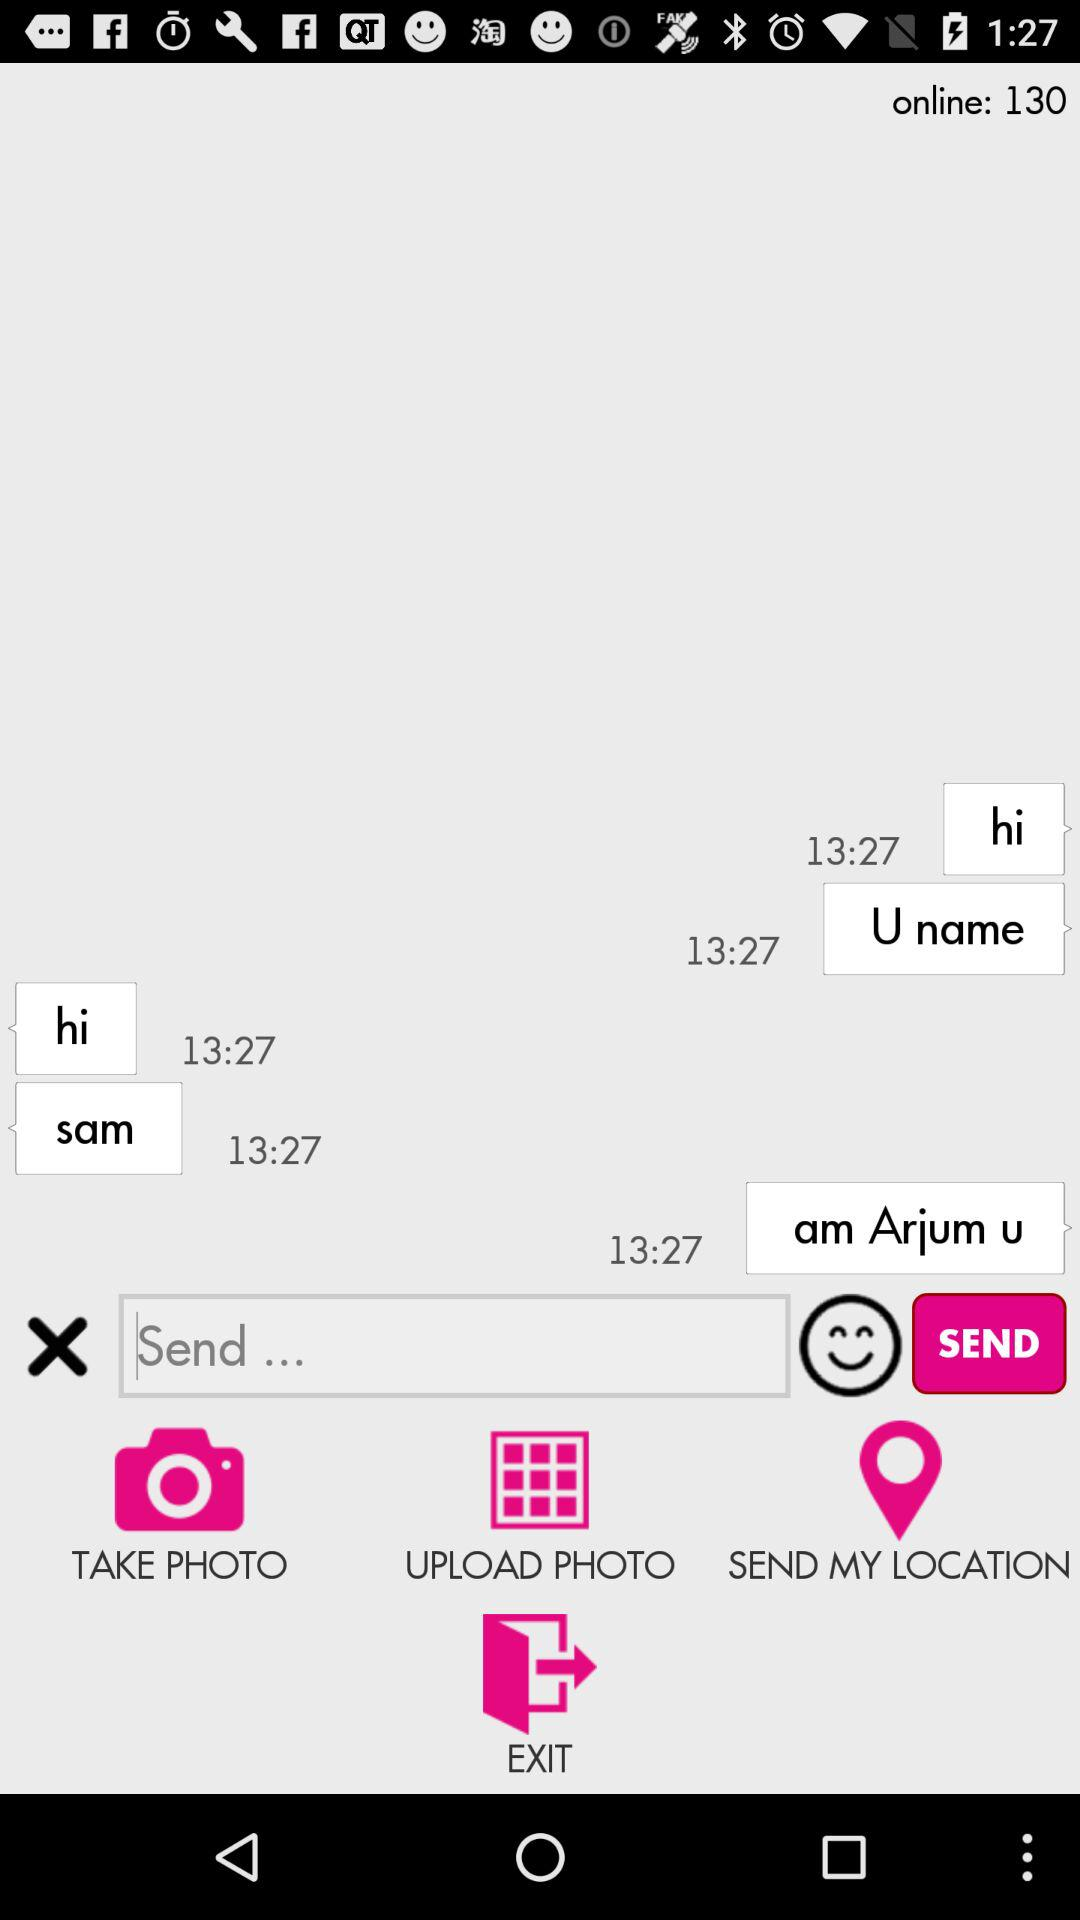How many users are online? There are 130 users online. 